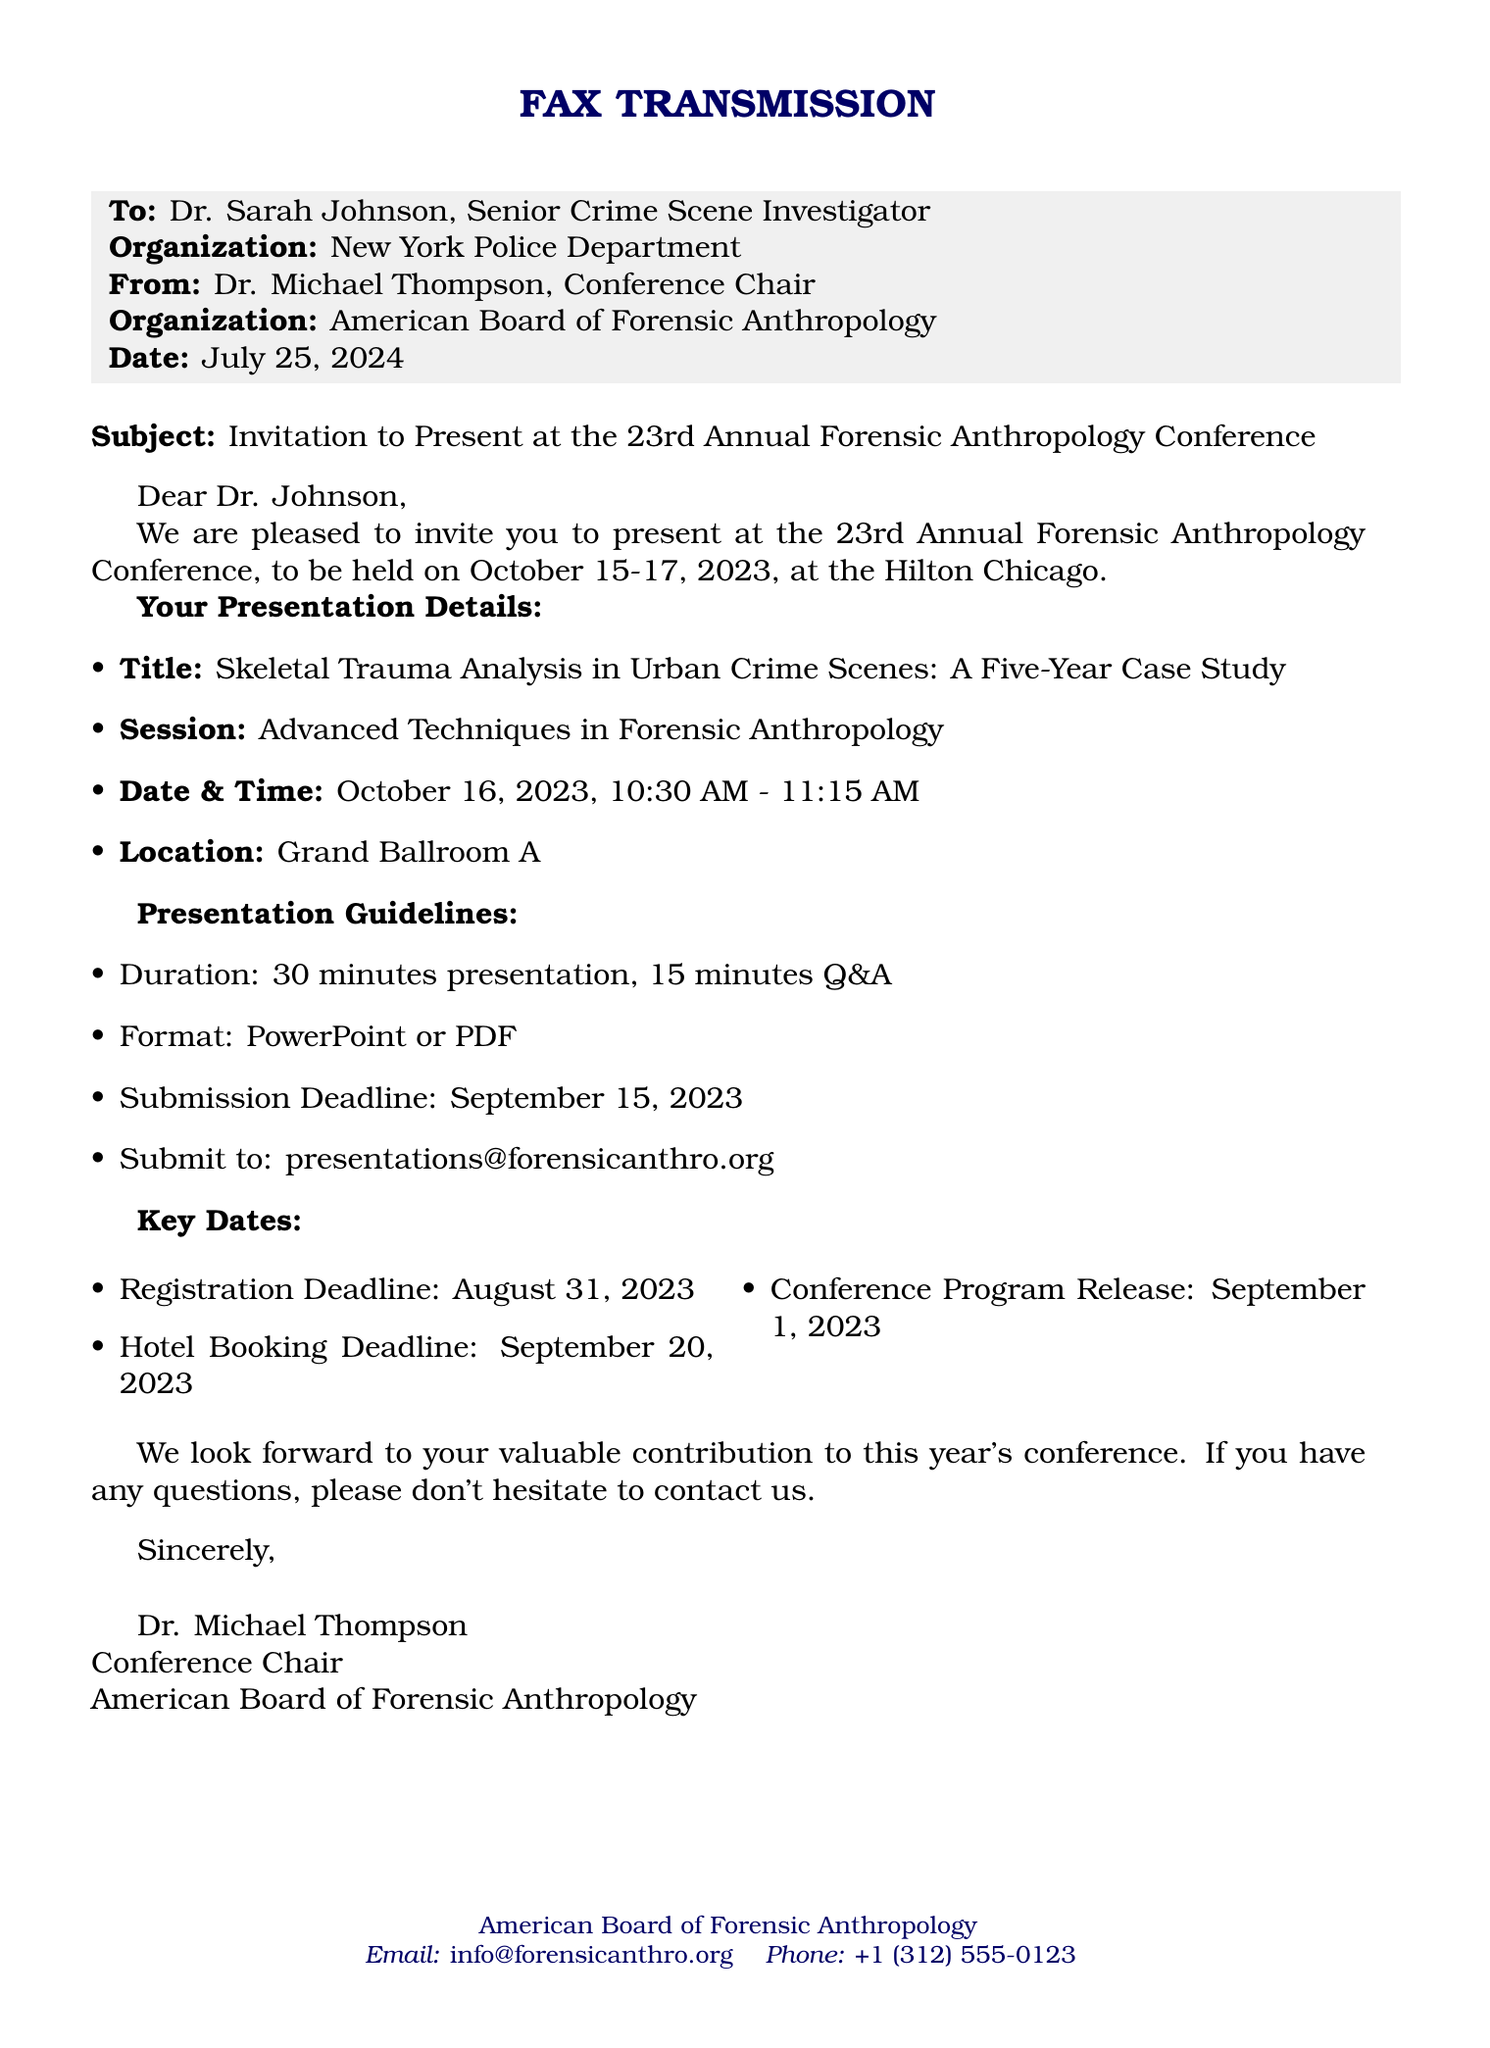what is the title of the presentation? The title of the presentation is explicitly mentioned in the document under the presentation details section.
Answer: Skeletal Trauma Analysis in Urban Crime Scenes: A Five-Year Case Study when will the conference take place? The dates for the conference are mentioned at the beginning of the document.
Answer: October 15-17, 2023 who is the conference chair? The name of the conference chair is provided in the closing section of the document.
Answer: Dr. Michael Thompson what is the deadline for presentation submission? The deadline for presentation submission is specified in the presentation guidelines section.
Answer: September 15, 2023 for how long will the presentation last? The duration of the presentation is stated in the presentation guidelines section.
Answer: 30 minutes what is the location of the presentation? The location of the presentation is mentioned in the presentation details section.
Answer: Grand Ballroom A how many minutes are allocated for the Q&A session? The duration for the Q&A session is explicitly listed in the presentation guidelines section.
Answer: 15 minutes when is the registration deadline? The registration deadline is listed in the key dates section of the document.
Answer: August 31, 2023 what email should the presentation be submitted to? The email for submission is provided in the presentation guidelines section.
Answer: presentations@forensicanthro.org 